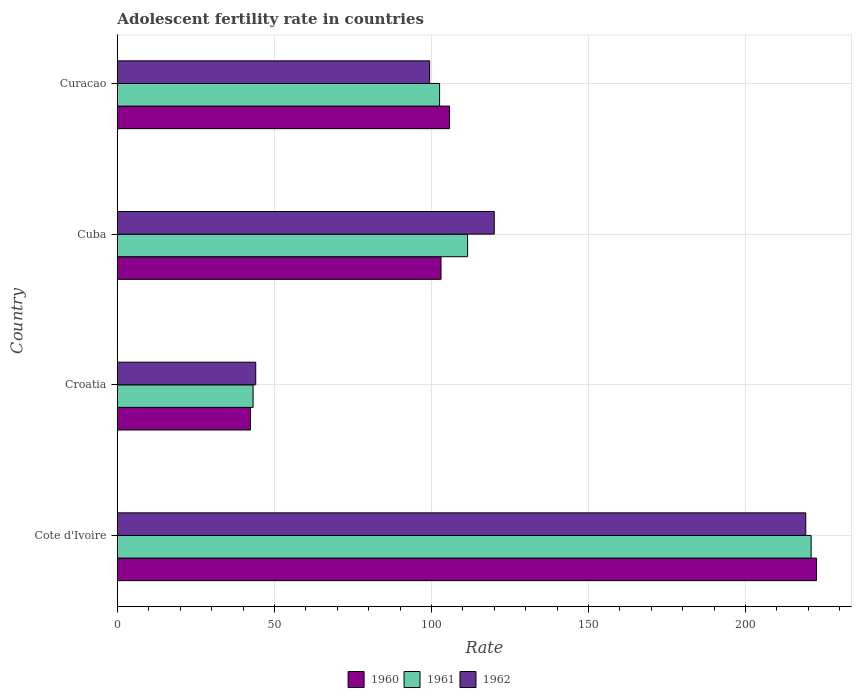Are the number of bars per tick equal to the number of legend labels?
Make the answer very short. Yes. Are the number of bars on each tick of the Y-axis equal?
Keep it short and to the point. Yes. How many bars are there on the 3rd tick from the top?
Make the answer very short. 3. How many bars are there on the 4th tick from the bottom?
Ensure brevity in your answer.  3. What is the label of the 4th group of bars from the top?
Provide a succinct answer. Cote d'Ivoire. In how many cases, is the number of bars for a given country not equal to the number of legend labels?
Your answer should be very brief. 0. What is the adolescent fertility rate in 1961 in Cote d'Ivoire?
Give a very brief answer. 220.9. Across all countries, what is the maximum adolescent fertility rate in 1960?
Keep it short and to the point. 222.62. Across all countries, what is the minimum adolescent fertility rate in 1960?
Provide a short and direct response. 42.37. In which country was the adolescent fertility rate in 1961 maximum?
Provide a short and direct response. Cote d'Ivoire. In which country was the adolescent fertility rate in 1962 minimum?
Provide a succinct answer. Croatia. What is the total adolescent fertility rate in 1961 in the graph?
Your answer should be compact. 478.21. What is the difference between the adolescent fertility rate in 1960 in Croatia and that in Cuba?
Ensure brevity in your answer.  -60.67. What is the difference between the adolescent fertility rate in 1962 in Croatia and the adolescent fertility rate in 1961 in Cuba?
Your response must be concise. -67.47. What is the average adolescent fertility rate in 1961 per country?
Provide a succinct answer. 119.55. What is the difference between the adolescent fertility rate in 1961 and adolescent fertility rate in 1962 in Cuba?
Provide a succinct answer. -8.48. What is the ratio of the adolescent fertility rate in 1961 in Cote d'Ivoire to that in Cuba?
Provide a succinct answer. 1.98. Is the adolescent fertility rate in 1960 in Croatia less than that in Curacao?
Ensure brevity in your answer.  Yes. Is the difference between the adolescent fertility rate in 1961 in Cote d'Ivoire and Curacao greater than the difference between the adolescent fertility rate in 1962 in Cote d'Ivoire and Curacao?
Provide a succinct answer. No. What is the difference between the highest and the second highest adolescent fertility rate in 1961?
Your answer should be compact. 109.38. What is the difference between the highest and the lowest adolescent fertility rate in 1961?
Provide a succinct answer. 177.69. In how many countries, is the adolescent fertility rate in 1960 greater than the average adolescent fertility rate in 1960 taken over all countries?
Your answer should be compact. 1. Is the sum of the adolescent fertility rate in 1962 in Cote d'Ivoire and Curacao greater than the maximum adolescent fertility rate in 1961 across all countries?
Keep it short and to the point. Yes. What does the 2nd bar from the bottom in Cote d'Ivoire represents?
Your answer should be very brief. 1961. Are all the bars in the graph horizontal?
Make the answer very short. Yes. How many countries are there in the graph?
Make the answer very short. 4. What is the difference between two consecutive major ticks on the X-axis?
Make the answer very short. 50. Does the graph contain grids?
Provide a short and direct response. Yes. How are the legend labels stacked?
Your answer should be very brief. Horizontal. What is the title of the graph?
Ensure brevity in your answer.  Adolescent fertility rate in countries. Does "1998" appear as one of the legend labels in the graph?
Keep it short and to the point. No. What is the label or title of the X-axis?
Offer a terse response. Rate. What is the Rate in 1960 in Cote d'Ivoire?
Your response must be concise. 222.62. What is the Rate of 1961 in Cote d'Ivoire?
Your answer should be compact. 220.9. What is the Rate in 1962 in Cote d'Ivoire?
Offer a very short reply. 219.18. What is the Rate of 1960 in Croatia?
Provide a short and direct response. 42.37. What is the Rate in 1961 in Croatia?
Provide a succinct answer. 43.21. What is the Rate of 1962 in Croatia?
Make the answer very short. 44.05. What is the Rate in 1960 in Cuba?
Ensure brevity in your answer.  103.04. What is the Rate of 1961 in Cuba?
Keep it short and to the point. 111.52. What is the Rate in 1962 in Cuba?
Provide a succinct answer. 120. What is the Rate of 1960 in Curacao?
Your answer should be compact. 105.75. What is the Rate in 1961 in Curacao?
Your answer should be very brief. 102.59. What is the Rate in 1962 in Curacao?
Keep it short and to the point. 99.42. Across all countries, what is the maximum Rate of 1960?
Make the answer very short. 222.62. Across all countries, what is the maximum Rate in 1961?
Keep it short and to the point. 220.9. Across all countries, what is the maximum Rate of 1962?
Keep it short and to the point. 219.18. Across all countries, what is the minimum Rate in 1960?
Offer a very short reply. 42.37. Across all countries, what is the minimum Rate in 1961?
Your answer should be very brief. 43.21. Across all countries, what is the minimum Rate in 1962?
Ensure brevity in your answer.  44.05. What is the total Rate in 1960 in the graph?
Provide a succinct answer. 473.78. What is the total Rate of 1961 in the graph?
Provide a succinct answer. 478.21. What is the total Rate in 1962 in the graph?
Keep it short and to the point. 482.64. What is the difference between the Rate of 1960 in Cote d'Ivoire and that in Croatia?
Ensure brevity in your answer.  180.25. What is the difference between the Rate in 1961 in Cote d'Ivoire and that in Croatia?
Your response must be concise. 177.69. What is the difference between the Rate in 1962 in Cote d'Ivoire and that in Croatia?
Keep it short and to the point. 175.14. What is the difference between the Rate in 1960 in Cote d'Ivoire and that in Cuba?
Keep it short and to the point. 119.58. What is the difference between the Rate of 1961 in Cote d'Ivoire and that in Cuba?
Your response must be concise. 109.38. What is the difference between the Rate in 1962 in Cote d'Ivoire and that in Cuba?
Provide a succinct answer. 99.18. What is the difference between the Rate in 1960 in Cote d'Ivoire and that in Curacao?
Ensure brevity in your answer.  116.86. What is the difference between the Rate in 1961 in Cote d'Ivoire and that in Curacao?
Offer a very short reply. 118.31. What is the difference between the Rate of 1962 in Cote d'Ivoire and that in Curacao?
Provide a short and direct response. 119.76. What is the difference between the Rate of 1960 in Croatia and that in Cuba?
Ensure brevity in your answer.  -60.67. What is the difference between the Rate in 1961 in Croatia and that in Cuba?
Ensure brevity in your answer.  -68.31. What is the difference between the Rate of 1962 in Croatia and that in Cuba?
Keep it short and to the point. -75.95. What is the difference between the Rate of 1960 in Croatia and that in Curacao?
Keep it short and to the point. -63.39. What is the difference between the Rate of 1961 in Croatia and that in Curacao?
Provide a succinct answer. -59.38. What is the difference between the Rate in 1962 in Croatia and that in Curacao?
Your answer should be compact. -55.37. What is the difference between the Rate of 1960 in Cuba and that in Curacao?
Keep it short and to the point. -2.71. What is the difference between the Rate of 1961 in Cuba and that in Curacao?
Offer a very short reply. 8.93. What is the difference between the Rate in 1962 in Cuba and that in Curacao?
Your answer should be very brief. 20.58. What is the difference between the Rate in 1960 in Cote d'Ivoire and the Rate in 1961 in Croatia?
Your response must be concise. 179.41. What is the difference between the Rate of 1960 in Cote d'Ivoire and the Rate of 1962 in Croatia?
Offer a very short reply. 178.57. What is the difference between the Rate in 1961 in Cote d'Ivoire and the Rate in 1962 in Croatia?
Keep it short and to the point. 176.85. What is the difference between the Rate in 1960 in Cote d'Ivoire and the Rate in 1961 in Cuba?
Keep it short and to the point. 111.1. What is the difference between the Rate of 1960 in Cote d'Ivoire and the Rate of 1962 in Cuba?
Make the answer very short. 102.62. What is the difference between the Rate in 1961 in Cote d'Ivoire and the Rate in 1962 in Cuba?
Provide a short and direct response. 100.9. What is the difference between the Rate of 1960 in Cote d'Ivoire and the Rate of 1961 in Curacao?
Provide a short and direct response. 120.03. What is the difference between the Rate of 1960 in Cote d'Ivoire and the Rate of 1962 in Curacao?
Your answer should be compact. 123.2. What is the difference between the Rate in 1961 in Cote d'Ivoire and the Rate in 1962 in Curacao?
Your response must be concise. 121.48. What is the difference between the Rate of 1960 in Croatia and the Rate of 1961 in Cuba?
Make the answer very short. -69.15. What is the difference between the Rate in 1960 in Croatia and the Rate in 1962 in Cuba?
Give a very brief answer. -77.63. What is the difference between the Rate in 1961 in Croatia and the Rate in 1962 in Cuba?
Your answer should be very brief. -76.79. What is the difference between the Rate in 1960 in Croatia and the Rate in 1961 in Curacao?
Offer a very short reply. -60.22. What is the difference between the Rate of 1960 in Croatia and the Rate of 1962 in Curacao?
Offer a terse response. -57.05. What is the difference between the Rate of 1961 in Croatia and the Rate of 1962 in Curacao?
Keep it short and to the point. -56.21. What is the difference between the Rate in 1960 in Cuba and the Rate in 1961 in Curacao?
Keep it short and to the point. 0.45. What is the difference between the Rate of 1960 in Cuba and the Rate of 1962 in Curacao?
Offer a terse response. 3.62. What is the difference between the Rate of 1961 in Cuba and the Rate of 1962 in Curacao?
Your answer should be compact. 12.1. What is the average Rate in 1960 per country?
Offer a terse response. 118.44. What is the average Rate of 1961 per country?
Make the answer very short. 119.55. What is the average Rate of 1962 per country?
Keep it short and to the point. 120.66. What is the difference between the Rate of 1960 and Rate of 1961 in Cote d'Ivoire?
Keep it short and to the point. 1.72. What is the difference between the Rate in 1960 and Rate in 1962 in Cote d'Ivoire?
Make the answer very short. 3.44. What is the difference between the Rate in 1961 and Rate in 1962 in Cote d'Ivoire?
Offer a very short reply. 1.72. What is the difference between the Rate of 1960 and Rate of 1961 in Croatia?
Provide a short and direct response. -0.84. What is the difference between the Rate in 1960 and Rate in 1962 in Croatia?
Make the answer very short. -1.68. What is the difference between the Rate of 1961 and Rate of 1962 in Croatia?
Provide a short and direct response. -0.84. What is the difference between the Rate in 1960 and Rate in 1961 in Cuba?
Provide a succinct answer. -8.48. What is the difference between the Rate of 1960 and Rate of 1962 in Cuba?
Make the answer very short. -16.96. What is the difference between the Rate in 1961 and Rate in 1962 in Cuba?
Ensure brevity in your answer.  -8.48. What is the difference between the Rate of 1960 and Rate of 1961 in Curacao?
Ensure brevity in your answer.  3.17. What is the difference between the Rate of 1960 and Rate of 1962 in Curacao?
Your answer should be very brief. 6.34. What is the difference between the Rate of 1961 and Rate of 1962 in Curacao?
Offer a very short reply. 3.17. What is the ratio of the Rate in 1960 in Cote d'Ivoire to that in Croatia?
Your response must be concise. 5.25. What is the ratio of the Rate in 1961 in Cote d'Ivoire to that in Croatia?
Offer a very short reply. 5.11. What is the ratio of the Rate in 1962 in Cote d'Ivoire to that in Croatia?
Your answer should be very brief. 4.98. What is the ratio of the Rate in 1960 in Cote d'Ivoire to that in Cuba?
Offer a terse response. 2.16. What is the ratio of the Rate of 1961 in Cote d'Ivoire to that in Cuba?
Ensure brevity in your answer.  1.98. What is the ratio of the Rate of 1962 in Cote d'Ivoire to that in Cuba?
Your answer should be compact. 1.83. What is the ratio of the Rate of 1960 in Cote d'Ivoire to that in Curacao?
Make the answer very short. 2.1. What is the ratio of the Rate in 1961 in Cote d'Ivoire to that in Curacao?
Make the answer very short. 2.15. What is the ratio of the Rate of 1962 in Cote d'Ivoire to that in Curacao?
Ensure brevity in your answer.  2.2. What is the ratio of the Rate in 1960 in Croatia to that in Cuba?
Your answer should be compact. 0.41. What is the ratio of the Rate of 1961 in Croatia to that in Cuba?
Ensure brevity in your answer.  0.39. What is the ratio of the Rate of 1962 in Croatia to that in Cuba?
Your response must be concise. 0.37. What is the ratio of the Rate of 1960 in Croatia to that in Curacao?
Your answer should be compact. 0.4. What is the ratio of the Rate of 1961 in Croatia to that in Curacao?
Offer a terse response. 0.42. What is the ratio of the Rate of 1962 in Croatia to that in Curacao?
Provide a short and direct response. 0.44. What is the ratio of the Rate of 1960 in Cuba to that in Curacao?
Your answer should be very brief. 0.97. What is the ratio of the Rate of 1961 in Cuba to that in Curacao?
Keep it short and to the point. 1.09. What is the ratio of the Rate of 1962 in Cuba to that in Curacao?
Your answer should be very brief. 1.21. What is the difference between the highest and the second highest Rate in 1960?
Provide a short and direct response. 116.86. What is the difference between the highest and the second highest Rate in 1961?
Provide a short and direct response. 109.38. What is the difference between the highest and the second highest Rate in 1962?
Provide a succinct answer. 99.18. What is the difference between the highest and the lowest Rate in 1960?
Give a very brief answer. 180.25. What is the difference between the highest and the lowest Rate in 1961?
Offer a terse response. 177.69. What is the difference between the highest and the lowest Rate in 1962?
Provide a short and direct response. 175.14. 